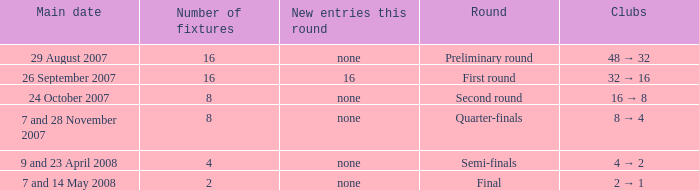What is the sum of Number of fixtures when the rounds shows quarter-finals? 8.0. 